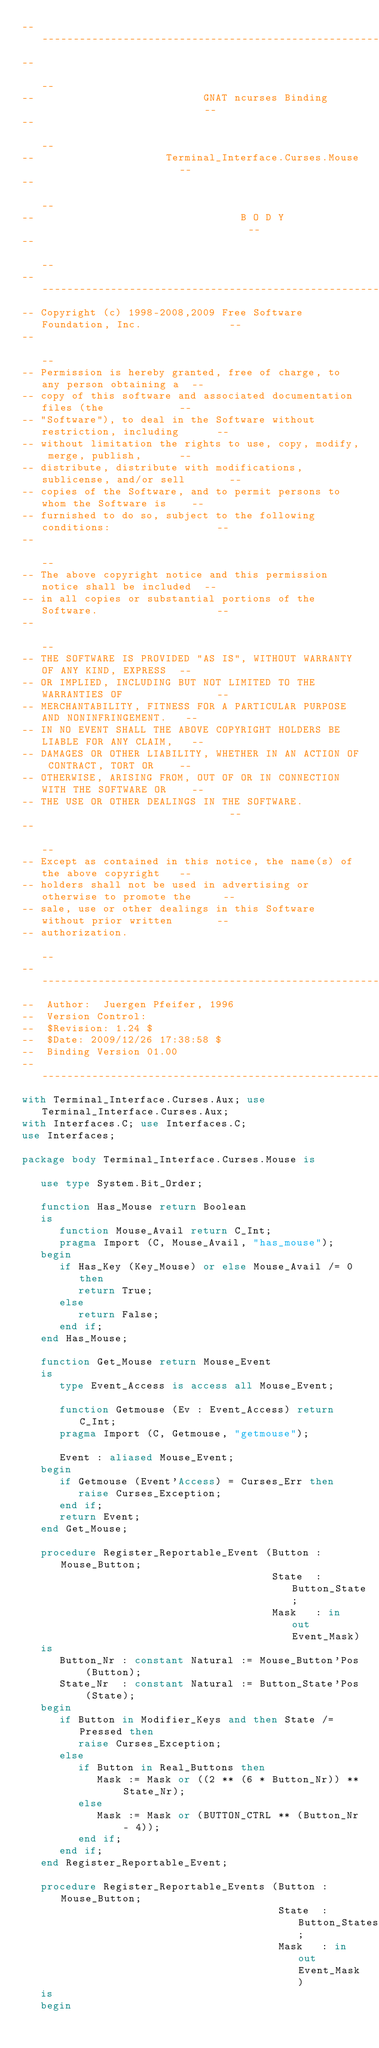<code> <loc_0><loc_0><loc_500><loc_500><_Ada_>------------------------------------------------------------------------------
--                                                                          --
--                           GNAT ncurses Binding                           --
--                                                                          --
--                     Terminal_Interface.Curses.Mouse                      --
--                                                                          --
--                                 B O D Y                                  --
--                                                                          --
------------------------------------------------------------------------------
-- Copyright (c) 1998-2008,2009 Free Software Foundation, Inc.              --
--                                                                          --
-- Permission is hereby granted, free of charge, to any person obtaining a  --
-- copy of this software and associated documentation files (the            --
-- "Software"), to deal in the Software without restriction, including      --
-- without limitation the rights to use, copy, modify, merge, publish,      --
-- distribute, distribute with modifications, sublicense, and/or sell       --
-- copies of the Software, and to permit persons to whom the Software is    --
-- furnished to do so, subject to the following conditions:                 --
--                                                                          --
-- The above copyright notice and this permission notice shall be included  --
-- in all copies or substantial portions of the Software.                   --
--                                                                          --
-- THE SOFTWARE IS PROVIDED "AS IS", WITHOUT WARRANTY OF ANY KIND, EXPRESS  --
-- OR IMPLIED, INCLUDING BUT NOT LIMITED TO THE WARRANTIES OF               --
-- MERCHANTABILITY, FITNESS FOR A PARTICULAR PURPOSE AND NONINFRINGEMENT.   --
-- IN NO EVENT SHALL THE ABOVE COPYRIGHT HOLDERS BE LIABLE FOR ANY CLAIM,   --
-- DAMAGES OR OTHER LIABILITY, WHETHER IN AN ACTION OF CONTRACT, TORT OR    --
-- OTHERWISE, ARISING FROM, OUT OF OR IN CONNECTION WITH THE SOFTWARE OR    --
-- THE USE OR OTHER DEALINGS IN THE SOFTWARE.                               --
--                                                                          --
-- Except as contained in this notice, the name(s) of the above copyright   --
-- holders shall not be used in advertising or otherwise to promote the     --
-- sale, use or other dealings in this Software without prior written       --
-- authorization.                                                           --
------------------------------------------------------------------------------
--  Author:  Juergen Pfeifer, 1996
--  Version Control:
--  $Revision: 1.24 $
--  $Date: 2009/12/26 17:38:58 $
--  Binding Version 01.00
------------------------------------------------------------------------------
with Terminal_Interface.Curses.Aux; use Terminal_Interface.Curses.Aux;
with Interfaces.C; use Interfaces.C;
use Interfaces;

package body Terminal_Interface.Curses.Mouse is

   use type System.Bit_Order;

   function Has_Mouse return Boolean
   is
      function Mouse_Avail return C_Int;
      pragma Import (C, Mouse_Avail, "has_mouse");
   begin
      if Has_Key (Key_Mouse) or else Mouse_Avail /= 0 then
         return True;
      else
         return False;
      end if;
   end Has_Mouse;

   function Get_Mouse return Mouse_Event
   is
      type Event_Access is access all Mouse_Event;

      function Getmouse (Ev : Event_Access) return C_Int;
      pragma Import (C, Getmouse, "getmouse");

      Event : aliased Mouse_Event;
   begin
      if Getmouse (Event'Access) = Curses_Err then
         raise Curses_Exception;
      end if;
      return Event;
   end Get_Mouse;

   procedure Register_Reportable_Event (Button : Mouse_Button;
                                        State  : Button_State;
                                        Mask   : in out Event_Mask)
   is
      Button_Nr : constant Natural := Mouse_Button'Pos (Button);
      State_Nr  : constant Natural := Button_State'Pos (State);
   begin
      if Button in Modifier_Keys and then State /= Pressed then
         raise Curses_Exception;
      else
         if Button in Real_Buttons then
            Mask := Mask or ((2 ** (6 * Button_Nr)) ** State_Nr);
         else
            Mask := Mask or (BUTTON_CTRL ** (Button_Nr - 4));
         end if;
      end if;
   end Register_Reportable_Event;

   procedure Register_Reportable_Events (Button : Mouse_Button;
                                         State  : Button_States;
                                         Mask   : in out Event_Mask)
   is
   begin</code> 